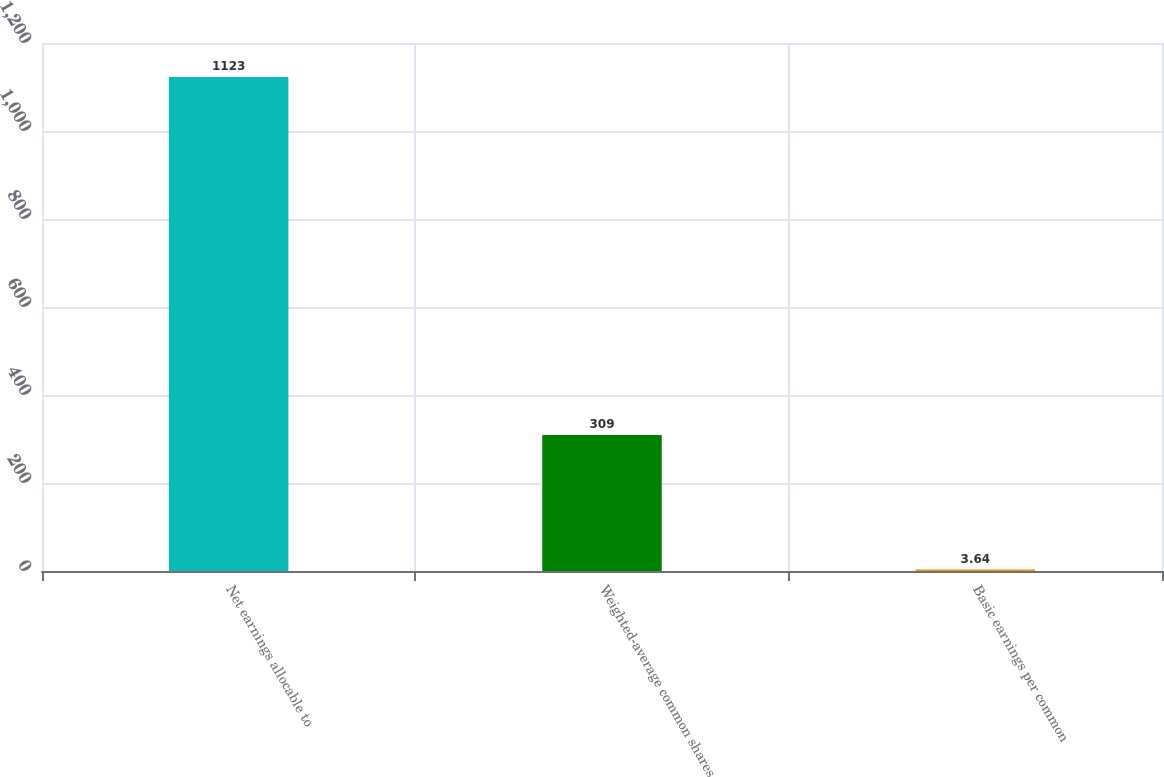Convert chart to OTSL. <chart><loc_0><loc_0><loc_500><loc_500><bar_chart><fcel>Net earnings allocable to<fcel>Weighted-average common shares<fcel>Basic earnings per common<nl><fcel>1123<fcel>309<fcel>3.64<nl></chart> 